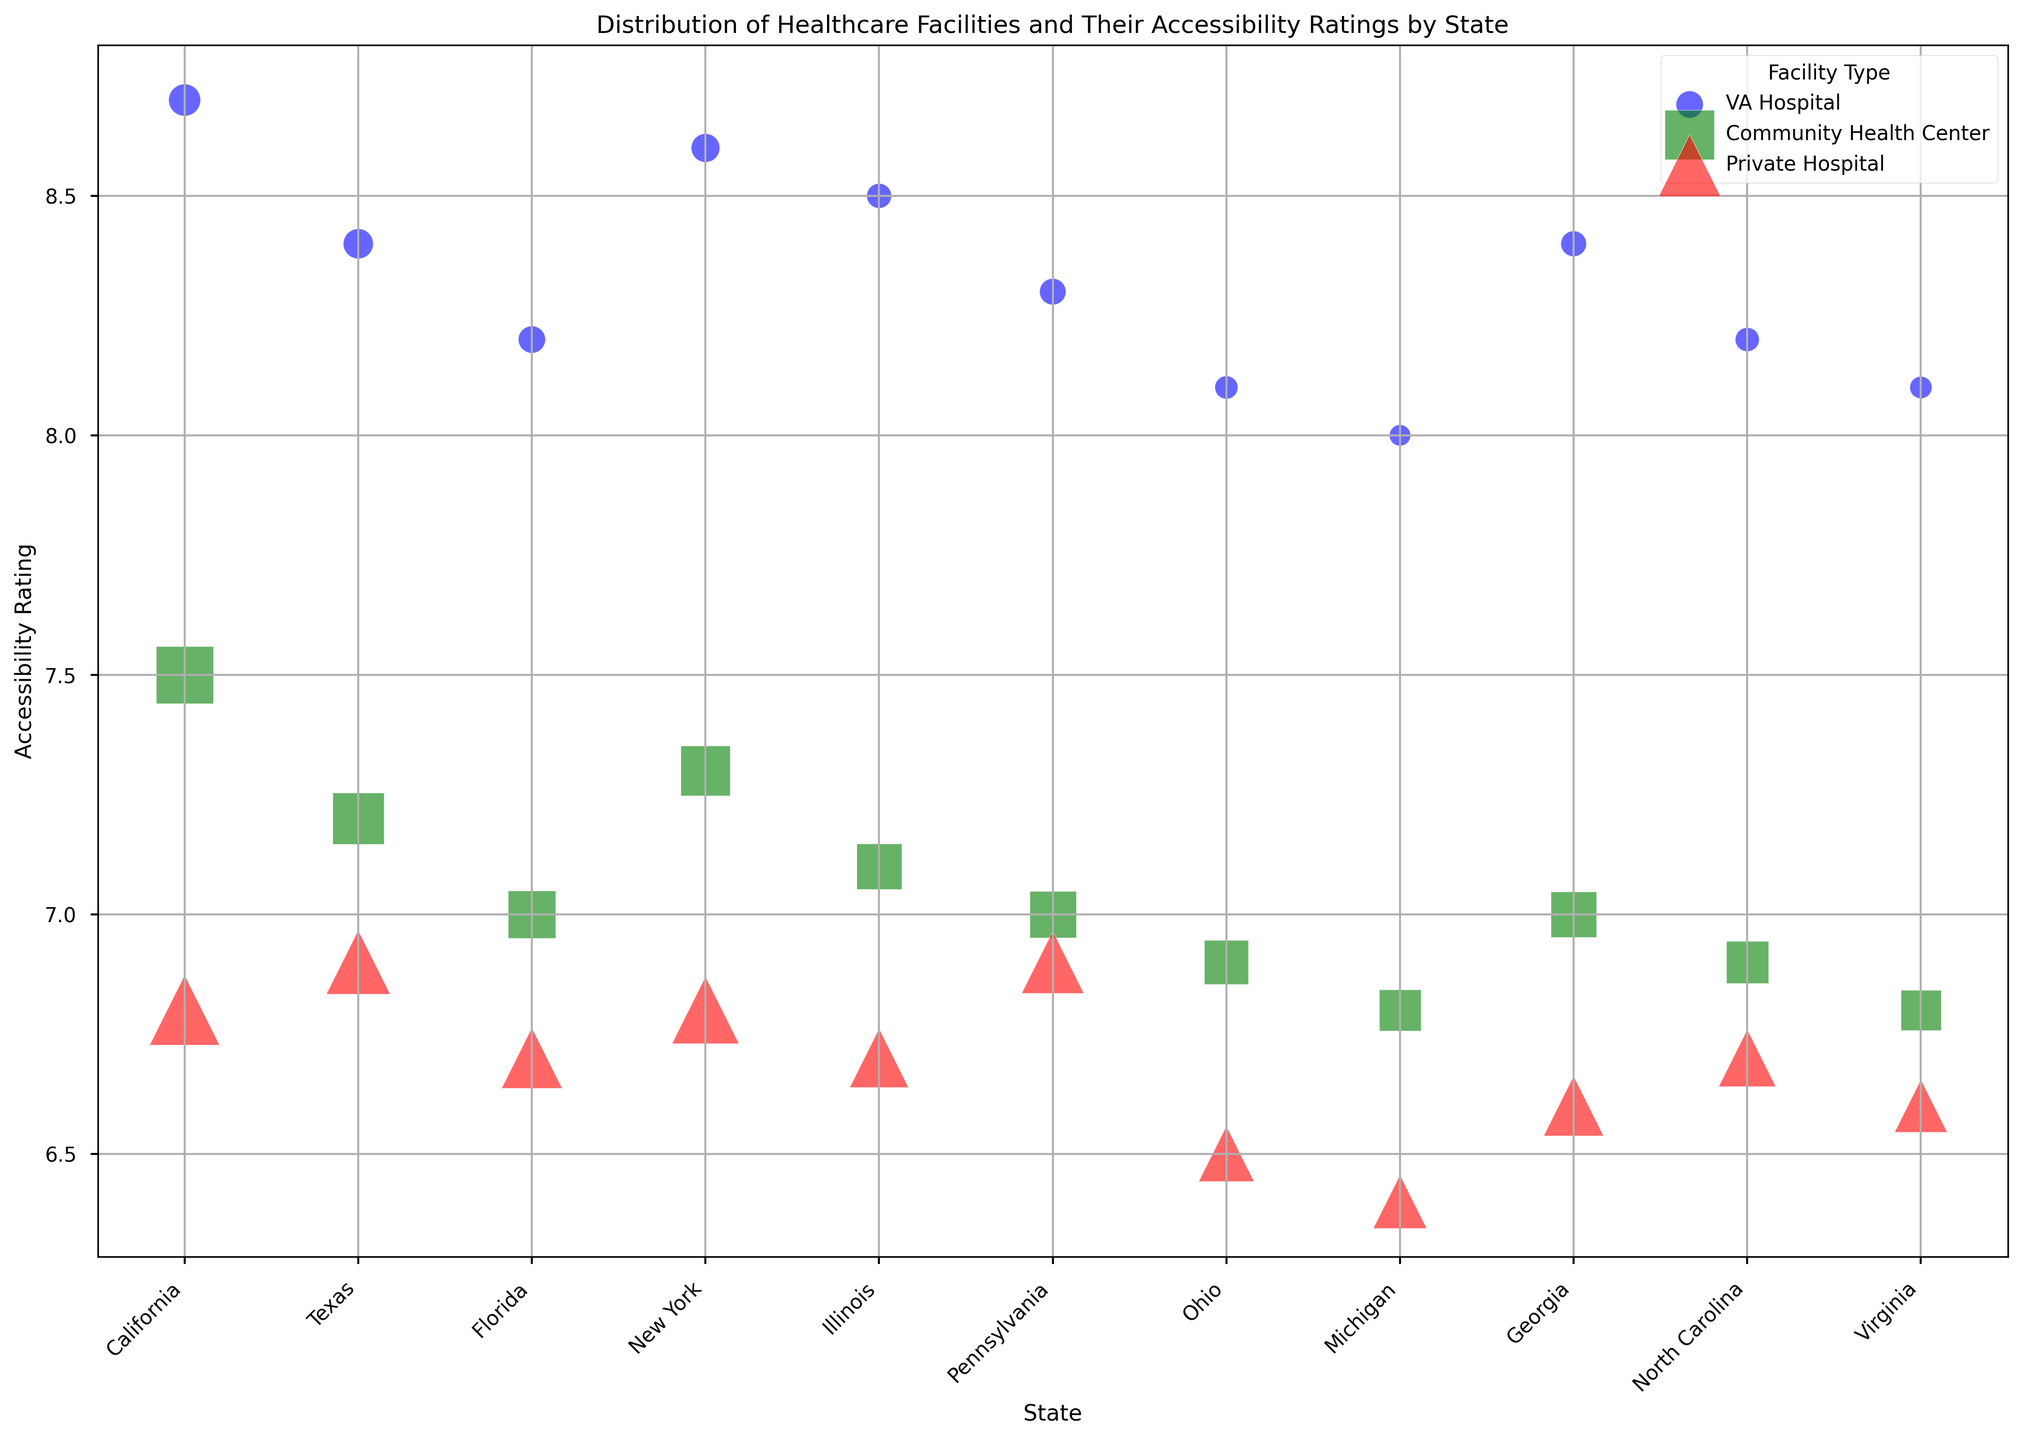Which state has the highest accessibility rating for VA Hospitals? Look at the vertical axis where VA Hospitals (represented by blue circles) are plotted. California has the highest accessibility rating among VA Hospitals with a rating of 8.7.
Answer: California How many community health centers are there in Texas and what is their combined accessibility rating total? Find the green squares for Texas which represent Community Health Centers. There are 65 centers with an accessibility rating of 7.2. To get the combined accessibility rating total, multiply the count by the rating: 65 * 7.2 = 468.
Answer: 468 Which type of healthcare facility has the largest number of facilities in California? Look at the size of the bubbles in California for the different types: VA Hospital (blue circle), Community Health Center (green square), and Private Hospital (red triangle). The red triangle (Private Hospital) appears to be the largest with 120 facilities.
Answer: Private Hospital Compare the accessibility ratings of Private Hospitals between New York and Ohio. Which state has a better average rating? Look at the red triangles in New York and Ohio. New York's Private Hospitals have an accessibility rating of 6.8, while Ohio's Private Hospitals have a rating of 6.5. Therefore, New York has a better average rating.
Answer: New York Does Illinois or Florida have a higher number of Community Health Centers, and by how much? Compare the green squares in Illinois and Florida. Illinois has 50 Community Health Centers, while Florida has 55. The difference is 55 - 50 = 5.
Answer: Florida by 5 What is the overall trend in accessibility ratings across different facility types? Observe the placement of bubbles along the vertical axis (Accessibility Rating). VA Hospitals generally have the highest accessibility ratings, followed by Community Health Centers, and then Private Hospitals with the lowest ratings across all states.
Answer: VA Hospitals > Community Health Centers > Private Hospitals Calculate the average accessibility rating for Community Health Centers in the selected states. Sum the accessibility ratings for Community Health Centers and then divide by the number of states: (7.5 + 7.2 + 7.0 + 7.3 + 7.1 + 7.0 + 6.9 + 6.8 + 7.0 + 6.9 + 6.8) / 11 = 7.009.
Answer: 7.01 Which state has the highest number of healthcare facilities overall? Summing up the sizes of the bubbles for each state visually, California has the largest combined count (25+80+120=225), which is larger than any other state.
Answer: California 